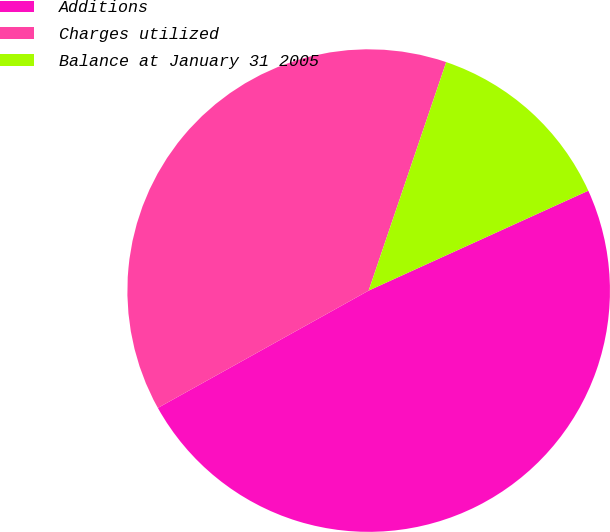<chart> <loc_0><loc_0><loc_500><loc_500><pie_chart><fcel>Additions<fcel>Charges utilized<fcel>Balance at January 31 2005<nl><fcel>48.71%<fcel>38.29%<fcel>13.0%<nl></chart> 